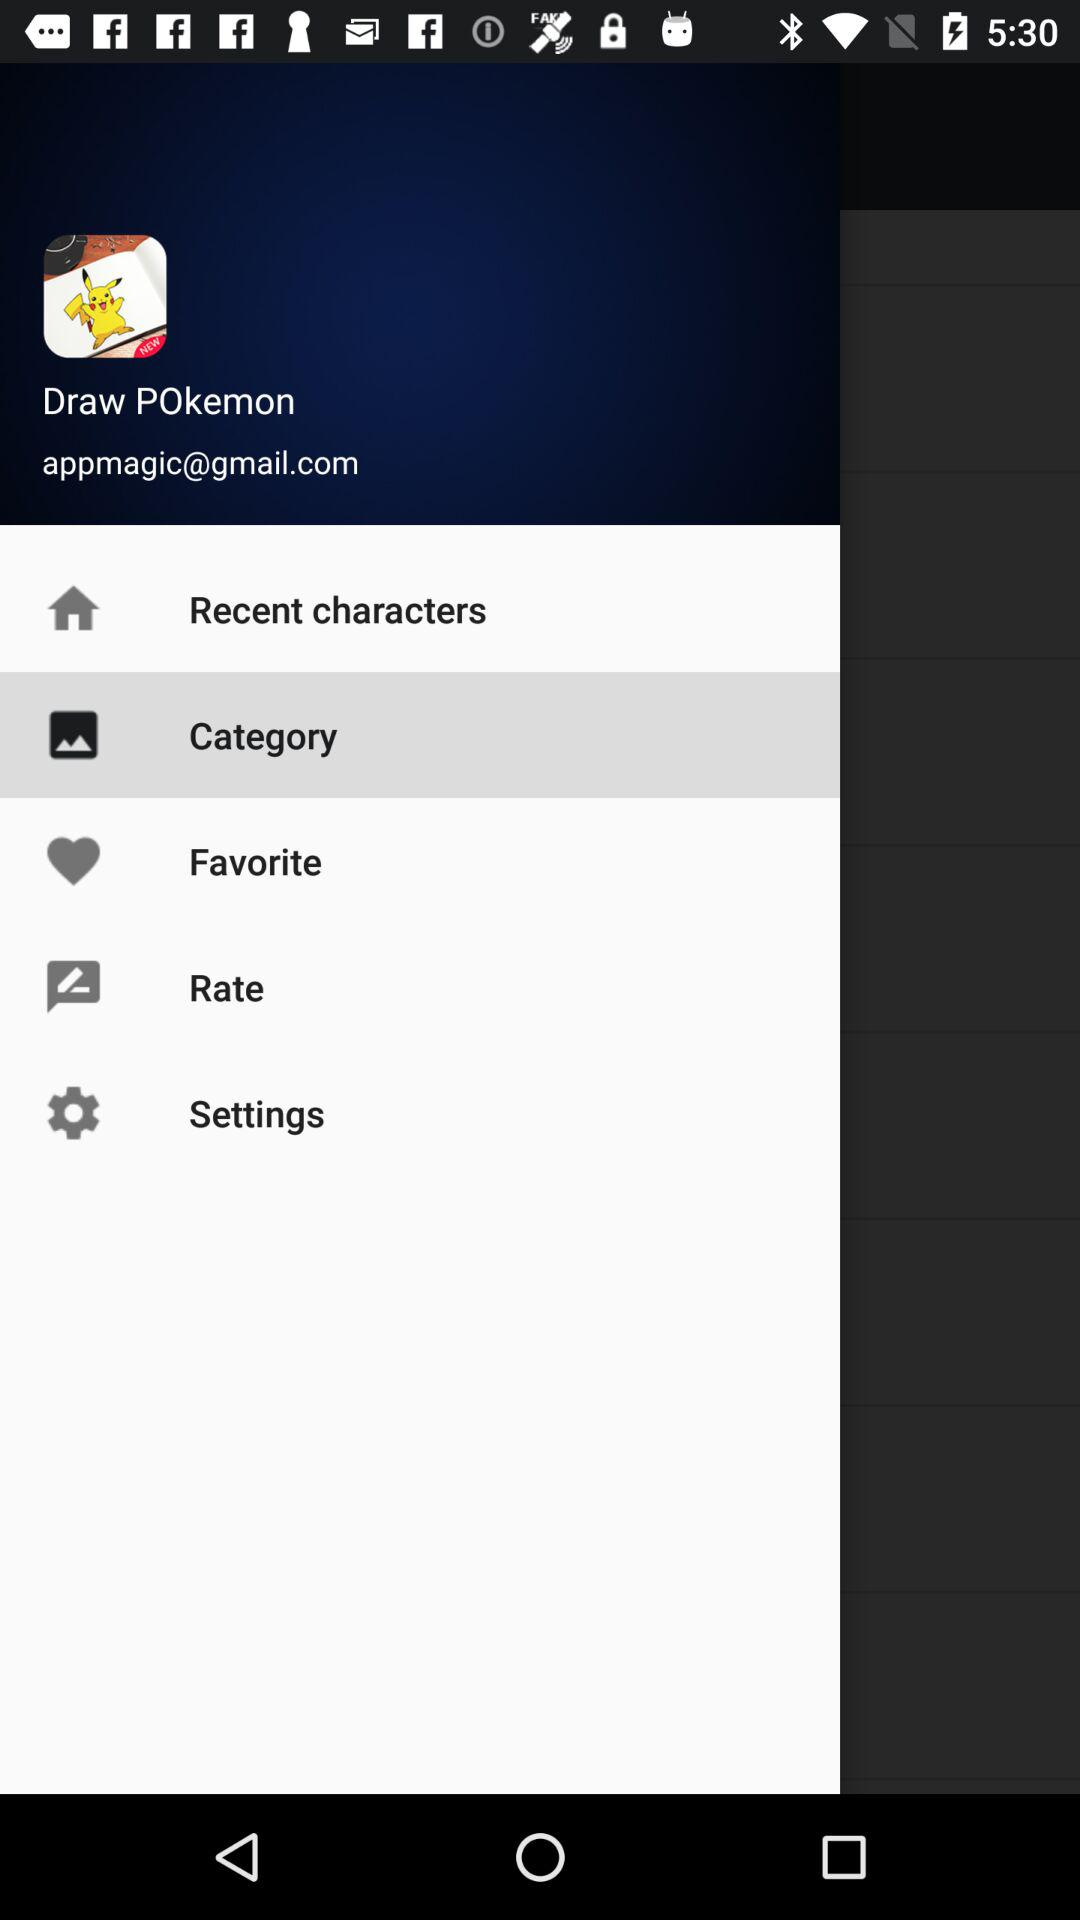What is the login name? The login name is Draw POkemon. 